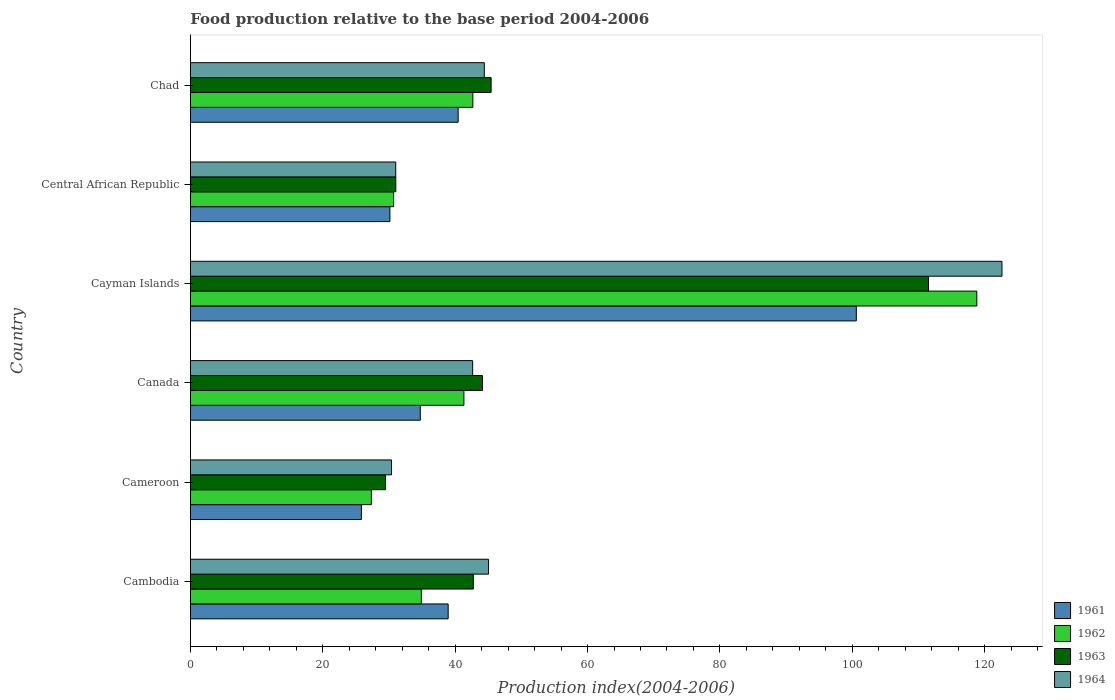How many different coloured bars are there?
Provide a succinct answer. 4. Are the number of bars on each tick of the Y-axis equal?
Offer a very short reply. Yes. How many bars are there on the 5th tick from the bottom?
Provide a short and direct response. 4. What is the label of the 6th group of bars from the top?
Your answer should be very brief. Cambodia. What is the food production index in 1964 in Central African Republic?
Provide a short and direct response. 31.03. Across all countries, what is the maximum food production index in 1964?
Give a very brief answer. 122.6. Across all countries, what is the minimum food production index in 1964?
Ensure brevity in your answer.  30.39. In which country was the food production index in 1964 maximum?
Make the answer very short. Cayman Islands. In which country was the food production index in 1962 minimum?
Your response must be concise. Cameroon. What is the total food production index in 1961 in the graph?
Ensure brevity in your answer.  270.74. What is the difference between the food production index in 1961 in Cayman Islands and that in Central African Republic?
Provide a short and direct response. 70.45. What is the difference between the food production index in 1964 in Cambodia and the food production index in 1962 in Canada?
Your answer should be very brief. 3.72. What is the average food production index in 1963 per country?
Your answer should be very brief. 50.73. What is the difference between the food production index in 1962 and food production index in 1963 in Chad?
Your response must be concise. -2.76. In how many countries, is the food production index in 1964 greater than 28 ?
Offer a terse response. 6. What is the ratio of the food production index in 1963 in Canada to that in Chad?
Provide a succinct answer. 0.97. What is the difference between the highest and the second highest food production index in 1964?
Ensure brevity in your answer.  77.55. What is the difference between the highest and the lowest food production index in 1962?
Make the answer very short. 91.45. In how many countries, is the food production index in 1963 greater than the average food production index in 1963 taken over all countries?
Make the answer very short. 1. What does the 1st bar from the bottom in Cameroon represents?
Make the answer very short. 1961. How many bars are there?
Offer a very short reply. 24. Are all the bars in the graph horizontal?
Offer a very short reply. Yes. What is the difference between two consecutive major ticks on the X-axis?
Offer a very short reply. 20. Are the values on the major ticks of X-axis written in scientific E-notation?
Give a very brief answer. No. Does the graph contain grids?
Provide a short and direct response. No. What is the title of the graph?
Give a very brief answer. Food production relative to the base period 2004-2006. What is the label or title of the X-axis?
Make the answer very short. Production index(2004-2006). What is the label or title of the Y-axis?
Provide a short and direct response. Country. What is the Production index(2004-2006) in 1961 in Cambodia?
Make the answer very short. 38.95. What is the Production index(2004-2006) of 1962 in Cambodia?
Keep it short and to the point. 34.9. What is the Production index(2004-2006) of 1963 in Cambodia?
Make the answer very short. 42.75. What is the Production index(2004-2006) in 1964 in Cambodia?
Offer a terse response. 45.05. What is the Production index(2004-2006) in 1961 in Cameroon?
Offer a very short reply. 25.84. What is the Production index(2004-2006) in 1962 in Cameroon?
Provide a short and direct response. 27.35. What is the Production index(2004-2006) of 1963 in Cameroon?
Your answer should be very brief. 29.49. What is the Production index(2004-2006) of 1964 in Cameroon?
Your answer should be compact. 30.39. What is the Production index(2004-2006) in 1961 in Canada?
Offer a very short reply. 34.74. What is the Production index(2004-2006) of 1962 in Canada?
Your answer should be very brief. 41.33. What is the Production index(2004-2006) in 1963 in Canada?
Ensure brevity in your answer.  44.13. What is the Production index(2004-2006) of 1964 in Canada?
Provide a short and direct response. 42.65. What is the Production index(2004-2006) in 1961 in Cayman Islands?
Your answer should be very brief. 100.6. What is the Production index(2004-2006) of 1962 in Cayman Islands?
Your answer should be compact. 118.8. What is the Production index(2004-2006) in 1963 in Cayman Islands?
Offer a terse response. 111.5. What is the Production index(2004-2006) in 1964 in Cayman Islands?
Offer a very short reply. 122.6. What is the Production index(2004-2006) in 1961 in Central African Republic?
Provide a succinct answer. 30.15. What is the Production index(2004-2006) in 1962 in Central African Republic?
Provide a succinct answer. 30.71. What is the Production index(2004-2006) of 1963 in Central African Republic?
Your answer should be compact. 31.04. What is the Production index(2004-2006) of 1964 in Central African Republic?
Give a very brief answer. 31.03. What is the Production index(2004-2006) in 1961 in Chad?
Your answer should be compact. 40.46. What is the Production index(2004-2006) in 1962 in Chad?
Give a very brief answer. 42.68. What is the Production index(2004-2006) in 1963 in Chad?
Offer a terse response. 45.44. What is the Production index(2004-2006) in 1964 in Chad?
Offer a terse response. 44.41. Across all countries, what is the maximum Production index(2004-2006) in 1961?
Keep it short and to the point. 100.6. Across all countries, what is the maximum Production index(2004-2006) in 1962?
Your answer should be compact. 118.8. Across all countries, what is the maximum Production index(2004-2006) in 1963?
Provide a succinct answer. 111.5. Across all countries, what is the maximum Production index(2004-2006) of 1964?
Offer a terse response. 122.6. Across all countries, what is the minimum Production index(2004-2006) of 1961?
Provide a succinct answer. 25.84. Across all countries, what is the minimum Production index(2004-2006) of 1962?
Your answer should be compact. 27.35. Across all countries, what is the minimum Production index(2004-2006) of 1963?
Offer a very short reply. 29.49. Across all countries, what is the minimum Production index(2004-2006) of 1964?
Your answer should be very brief. 30.39. What is the total Production index(2004-2006) of 1961 in the graph?
Make the answer very short. 270.74. What is the total Production index(2004-2006) in 1962 in the graph?
Ensure brevity in your answer.  295.77. What is the total Production index(2004-2006) of 1963 in the graph?
Provide a succinct answer. 304.35. What is the total Production index(2004-2006) of 1964 in the graph?
Offer a terse response. 316.13. What is the difference between the Production index(2004-2006) of 1961 in Cambodia and that in Cameroon?
Keep it short and to the point. 13.11. What is the difference between the Production index(2004-2006) in 1962 in Cambodia and that in Cameroon?
Your response must be concise. 7.55. What is the difference between the Production index(2004-2006) of 1963 in Cambodia and that in Cameroon?
Your answer should be compact. 13.26. What is the difference between the Production index(2004-2006) of 1964 in Cambodia and that in Cameroon?
Offer a very short reply. 14.66. What is the difference between the Production index(2004-2006) of 1961 in Cambodia and that in Canada?
Make the answer very short. 4.21. What is the difference between the Production index(2004-2006) of 1962 in Cambodia and that in Canada?
Make the answer very short. -6.43. What is the difference between the Production index(2004-2006) of 1963 in Cambodia and that in Canada?
Provide a succinct answer. -1.38. What is the difference between the Production index(2004-2006) in 1964 in Cambodia and that in Canada?
Make the answer very short. 2.4. What is the difference between the Production index(2004-2006) of 1961 in Cambodia and that in Cayman Islands?
Ensure brevity in your answer.  -61.65. What is the difference between the Production index(2004-2006) of 1962 in Cambodia and that in Cayman Islands?
Make the answer very short. -83.9. What is the difference between the Production index(2004-2006) of 1963 in Cambodia and that in Cayman Islands?
Offer a very short reply. -68.75. What is the difference between the Production index(2004-2006) in 1964 in Cambodia and that in Cayman Islands?
Your response must be concise. -77.55. What is the difference between the Production index(2004-2006) of 1962 in Cambodia and that in Central African Republic?
Your response must be concise. 4.19. What is the difference between the Production index(2004-2006) in 1963 in Cambodia and that in Central African Republic?
Give a very brief answer. 11.71. What is the difference between the Production index(2004-2006) in 1964 in Cambodia and that in Central African Republic?
Make the answer very short. 14.02. What is the difference between the Production index(2004-2006) in 1961 in Cambodia and that in Chad?
Your response must be concise. -1.51. What is the difference between the Production index(2004-2006) of 1962 in Cambodia and that in Chad?
Ensure brevity in your answer.  -7.78. What is the difference between the Production index(2004-2006) of 1963 in Cambodia and that in Chad?
Give a very brief answer. -2.69. What is the difference between the Production index(2004-2006) of 1964 in Cambodia and that in Chad?
Keep it short and to the point. 0.64. What is the difference between the Production index(2004-2006) in 1961 in Cameroon and that in Canada?
Your answer should be very brief. -8.9. What is the difference between the Production index(2004-2006) in 1962 in Cameroon and that in Canada?
Give a very brief answer. -13.98. What is the difference between the Production index(2004-2006) of 1963 in Cameroon and that in Canada?
Provide a succinct answer. -14.64. What is the difference between the Production index(2004-2006) in 1964 in Cameroon and that in Canada?
Provide a succinct answer. -12.26. What is the difference between the Production index(2004-2006) of 1961 in Cameroon and that in Cayman Islands?
Offer a very short reply. -74.76. What is the difference between the Production index(2004-2006) of 1962 in Cameroon and that in Cayman Islands?
Your response must be concise. -91.45. What is the difference between the Production index(2004-2006) of 1963 in Cameroon and that in Cayman Islands?
Your response must be concise. -82.01. What is the difference between the Production index(2004-2006) in 1964 in Cameroon and that in Cayman Islands?
Offer a terse response. -92.21. What is the difference between the Production index(2004-2006) in 1961 in Cameroon and that in Central African Republic?
Make the answer very short. -4.31. What is the difference between the Production index(2004-2006) in 1962 in Cameroon and that in Central African Republic?
Keep it short and to the point. -3.36. What is the difference between the Production index(2004-2006) of 1963 in Cameroon and that in Central African Republic?
Offer a very short reply. -1.55. What is the difference between the Production index(2004-2006) in 1964 in Cameroon and that in Central African Republic?
Provide a succinct answer. -0.64. What is the difference between the Production index(2004-2006) in 1961 in Cameroon and that in Chad?
Ensure brevity in your answer.  -14.62. What is the difference between the Production index(2004-2006) in 1962 in Cameroon and that in Chad?
Your response must be concise. -15.33. What is the difference between the Production index(2004-2006) in 1963 in Cameroon and that in Chad?
Provide a short and direct response. -15.95. What is the difference between the Production index(2004-2006) in 1964 in Cameroon and that in Chad?
Ensure brevity in your answer.  -14.02. What is the difference between the Production index(2004-2006) of 1961 in Canada and that in Cayman Islands?
Your answer should be very brief. -65.86. What is the difference between the Production index(2004-2006) in 1962 in Canada and that in Cayman Islands?
Ensure brevity in your answer.  -77.47. What is the difference between the Production index(2004-2006) in 1963 in Canada and that in Cayman Islands?
Your answer should be very brief. -67.37. What is the difference between the Production index(2004-2006) in 1964 in Canada and that in Cayman Islands?
Give a very brief answer. -79.95. What is the difference between the Production index(2004-2006) in 1961 in Canada and that in Central African Republic?
Ensure brevity in your answer.  4.59. What is the difference between the Production index(2004-2006) of 1962 in Canada and that in Central African Republic?
Keep it short and to the point. 10.62. What is the difference between the Production index(2004-2006) of 1963 in Canada and that in Central African Republic?
Your response must be concise. 13.09. What is the difference between the Production index(2004-2006) in 1964 in Canada and that in Central African Republic?
Offer a very short reply. 11.62. What is the difference between the Production index(2004-2006) in 1961 in Canada and that in Chad?
Ensure brevity in your answer.  -5.72. What is the difference between the Production index(2004-2006) in 1962 in Canada and that in Chad?
Provide a short and direct response. -1.35. What is the difference between the Production index(2004-2006) in 1963 in Canada and that in Chad?
Your answer should be very brief. -1.31. What is the difference between the Production index(2004-2006) of 1964 in Canada and that in Chad?
Keep it short and to the point. -1.76. What is the difference between the Production index(2004-2006) in 1961 in Cayman Islands and that in Central African Republic?
Your answer should be very brief. 70.45. What is the difference between the Production index(2004-2006) of 1962 in Cayman Islands and that in Central African Republic?
Your answer should be compact. 88.09. What is the difference between the Production index(2004-2006) of 1963 in Cayman Islands and that in Central African Republic?
Your response must be concise. 80.46. What is the difference between the Production index(2004-2006) of 1964 in Cayman Islands and that in Central African Republic?
Ensure brevity in your answer.  91.57. What is the difference between the Production index(2004-2006) of 1961 in Cayman Islands and that in Chad?
Make the answer very short. 60.14. What is the difference between the Production index(2004-2006) of 1962 in Cayman Islands and that in Chad?
Offer a terse response. 76.12. What is the difference between the Production index(2004-2006) in 1963 in Cayman Islands and that in Chad?
Provide a succinct answer. 66.06. What is the difference between the Production index(2004-2006) in 1964 in Cayman Islands and that in Chad?
Your answer should be very brief. 78.19. What is the difference between the Production index(2004-2006) in 1961 in Central African Republic and that in Chad?
Make the answer very short. -10.31. What is the difference between the Production index(2004-2006) of 1962 in Central African Republic and that in Chad?
Your response must be concise. -11.97. What is the difference between the Production index(2004-2006) of 1963 in Central African Republic and that in Chad?
Make the answer very short. -14.4. What is the difference between the Production index(2004-2006) in 1964 in Central African Republic and that in Chad?
Your response must be concise. -13.38. What is the difference between the Production index(2004-2006) in 1961 in Cambodia and the Production index(2004-2006) in 1963 in Cameroon?
Your answer should be very brief. 9.46. What is the difference between the Production index(2004-2006) in 1961 in Cambodia and the Production index(2004-2006) in 1964 in Cameroon?
Make the answer very short. 8.56. What is the difference between the Production index(2004-2006) of 1962 in Cambodia and the Production index(2004-2006) of 1963 in Cameroon?
Make the answer very short. 5.41. What is the difference between the Production index(2004-2006) in 1962 in Cambodia and the Production index(2004-2006) in 1964 in Cameroon?
Offer a terse response. 4.51. What is the difference between the Production index(2004-2006) of 1963 in Cambodia and the Production index(2004-2006) of 1964 in Cameroon?
Provide a short and direct response. 12.36. What is the difference between the Production index(2004-2006) in 1961 in Cambodia and the Production index(2004-2006) in 1962 in Canada?
Give a very brief answer. -2.38. What is the difference between the Production index(2004-2006) of 1961 in Cambodia and the Production index(2004-2006) of 1963 in Canada?
Ensure brevity in your answer.  -5.18. What is the difference between the Production index(2004-2006) of 1961 in Cambodia and the Production index(2004-2006) of 1964 in Canada?
Make the answer very short. -3.7. What is the difference between the Production index(2004-2006) in 1962 in Cambodia and the Production index(2004-2006) in 1963 in Canada?
Provide a short and direct response. -9.23. What is the difference between the Production index(2004-2006) of 1962 in Cambodia and the Production index(2004-2006) of 1964 in Canada?
Give a very brief answer. -7.75. What is the difference between the Production index(2004-2006) in 1963 in Cambodia and the Production index(2004-2006) in 1964 in Canada?
Offer a terse response. 0.1. What is the difference between the Production index(2004-2006) in 1961 in Cambodia and the Production index(2004-2006) in 1962 in Cayman Islands?
Make the answer very short. -79.85. What is the difference between the Production index(2004-2006) of 1961 in Cambodia and the Production index(2004-2006) of 1963 in Cayman Islands?
Provide a short and direct response. -72.55. What is the difference between the Production index(2004-2006) in 1961 in Cambodia and the Production index(2004-2006) in 1964 in Cayman Islands?
Your answer should be very brief. -83.65. What is the difference between the Production index(2004-2006) in 1962 in Cambodia and the Production index(2004-2006) in 1963 in Cayman Islands?
Your answer should be compact. -76.6. What is the difference between the Production index(2004-2006) of 1962 in Cambodia and the Production index(2004-2006) of 1964 in Cayman Islands?
Offer a terse response. -87.7. What is the difference between the Production index(2004-2006) of 1963 in Cambodia and the Production index(2004-2006) of 1964 in Cayman Islands?
Offer a very short reply. -79.85. What is the difference between the Production index(2004-2006) in 1961 in Cambodia and the Production index(2004-2006) in 1962 in Central African Republic?
Offer a terse response. 8.24. What is the difference between the Production index(2004-2006) in 1961 in Cambodia and the Production index(2004-2006) in 1963 in Central African Republic?
Provide a short and direct response. 7.91. What is the difference between the Production index(2004-2006) of 1961 in Cambodia and the Production index(2004-2006) of 1964 in Central African Republic?
Ensure brevity in your answer.  7.92. What is the difference between the Production index(2004-2006) in 1962 in Cambodia and the Production index(2004-2006) in 1963 in Central African Republic?
Offer a very short reply. 3.86. What is the difference between the Production index(2004-2006) of 1962 in Cambodia and the Production index(2004-2006) of 1964 in Central African Republic?
Make the answer very short. 3.87. What is the difference between the Production index(2004-2006) of 1963 in Cambodia and the Production index(2004-2006) of 1964 in Central African Republic?
Your response must be concise. 11.72. What is the difference between the Production index(2004-2006) in 1961 in Cambodia and the Production index(2004-2006) in 1962 in Chad?
Provide a succinct answer. -3.73. What is the difference between the Production index(2004-2006) of 1961 in Cambodia and the Production index(2004-2006) of 1963 in Chad?
Ensure brevity in your answer.  -6.49. What is the difference between the Production index(2004-2006) in 1961 in Cambodia and the Production index(2004-2006) in 1964 in Chad?
Your answer should be compact. -5.46. What is the difference between the Production index(2004-2006) in 1962 in Cambodia and the Production index(2004-2006) in 1963 in Chad?
Offer a very short reply. -10.54. What is the difference between the Production index(2004-2006) in 1962 in Cambodia and the Production index(2004-2006) in 1964 in Chad?
Your response must be concise. -9.51. What is the difference between the Production index(2004-2006) in 1963 in Cambodia and the Production index(2004-2006) in 1964 in Chad?
Offer a very short reply. -1.66. What is the difference between the Production index(2004-2006) in 1961 in Cameroon and the Production index(2004-2006) in 1962 in Canada?
Offer a terse response. -15.49. What is the difference between the Production index(2004-2006) of 1961 in Cameroon and the Production index(2004-2006) of 1963 in Canada?
Keep it short and to the point. -18.29. What is the difference between the Production index(2004-2006) in 1961 in Cameroon and the Production index(2004-2006) in 1964 in Canada?
Ensure brevity in your answer.  -16.81. What is the difference between the Production index(2004-2006) in 1962 in Cameroon and the Production index(2004-2006) in 1963 in Canada?
Offer a terse response. -16.78. What is the difference between the Production index(2004-2006) of 1962 in Cameroon and the Production index(2004-2006) of 1964 in Canada?
Your response must be concise. -15.3. What is the difference between the Production index(2004-2006) of 1963 in Cameroon and the Production index(2004-2006) of 1964 in Canada?
Your answer should be compact. -13.16. What is the difference between the Production index(2004-2006) of 1961 in Cameroon and the Production index(2004-2006) of 1962 in Cayman Islands?
Give a very brief answer. -92.96. What is the difference between the Production index(2004-2006) of 1961 in Cameroon and the Production index(2004-2006) of 1963 in Cayman Islands?
Offer a terse response. -85.66. What is the difference between the Production index(2004-2006) in 1961 in Cameroon and the Production index(2004-2006) in 1964 in Cayman Islands?
Your response must be concise. -96.76. What is the difference between the Production index(2004-2006) in 1962 in Cameroon and the Production index(2004-2006) in 1963 in Cayman Islands?
Ensure brevity in your answer.  -84.15. What is the difference between the Production index(2004-2006) in 1962 in Cameroon and the Production index(2004-2006) in 1964 in Cayman Islands?
Your response must be concise. -95.25. What is the difference between the Production index(2004-2006) of 1963 in Cameroon and the Production index(2004-2006) of 1964 in Cayman Islands?
Your answer should be very brief. -93.11. What is the difference between the Production index(2004-2006) of 1961 in Cameroon and the Production index(2004-2006) of 1962 in Central African Republic?
Ensure brevity in your answer.  -4.87. What is the difference between the Production index(2004-2006) in 1961 in Cameroon and the Production index(2004-2006) in 1964 in Central African Republic?
Your response must be concise. -5.19. What is the difference between the Production index(2004-2006) of 1962 in Cameroon and the Production index(2004-2006) of 1963 in Central African Republic?
Keep it short and to the point. -3.69. What is the difference between the Production index(2004-2006) of 1962 in Cameroon and the Production index(2004-2006) of 1964 in Central African Republic?
Your answer should be compact. -3.68. What is the difference between the Production index(2004-2006) of 1963 in Cameroon and the Production index(2004-2006) of 1964 in Central African Republic?
Keep it short and to the point. -1.54. What is the difference between the Production index(2004-2006) in 1961 in Cameroon and the Production index(2004-2006) in 1962 in Chad?
Provide a succinct answer. -16.84. What is the difference between the Production index(2004-2006) of 1961 in Cameroon and the Production index(2004-2006) of 1963 in Chad?
Offer a terse response. -19.6. What is the difference between the Production index(2004-2006) of 1961 in Cameroon and the Production index(2004-2006) of 1964 in Chad?
Your answer should be very brief. -18.57. What is the difference between the Production index(2004-2006) in 1962 in Cameroon and the Production index(2004-2006) in 1963 in Chad?
Your response must be concise. -18.09. What is the difference between the Production index(2004-2006) in 1962 in Cameroon and the Production index(2004-2006) in 1964 in Chad?
Provide a succinct answer. -17.06. What is the difference between the Production index(2004-2006) of 1963 in Cameroon and the Production index(2004-2006) of 1964 in Chad?
Offer a terse response. -14.92. What is the difference between the Production index(2004-2006) in 1961 in Canada and the Production index(2004-2006) in 1962 in Cayman Islands?
Provide a succinct answer. -84.06. What is the difference between the Production index(2004-2006) of 1961 in Canada and the Production index(2004-2006) of 1963 in Cayman Islands?
Give a very brief answer. -76.76. What is the difference between the Production index(2004-2006) of 1961 in Canada and the Production index(2004-2006) of 1964 in Cayman Islands?
Provide a succinct answer. -87.86. What is the difference between the Production index(2004-2006) in 1962 in Canada and the Production index(2004-2006) in 1963 in Cayman Islands?
Your answer should be very brief. -70.17. What is the difference between the Production index(2004-2006) of 1962 in Canada and the Production index(2004-2006) of 1964 in Cayman Islands?
Your answer should be compact. -81.27. What is the difference between the Production index(2004-2006) of 1963 in Canada and the Production index(2004-2006) of 1964 in Cayman Islands?
Make the answer very short. -78.47. What is the difference between the Production index(2004-2006) in 1961 in Canada and the Production index(2004-2006) in 1962 in Central African Republic?
Your answer should be compact. 4.03. What is the difference between the Production index(2004-2006) of 1961 in Canada and the Production index(2004-2006) of 1964 in Central African Republic?
Your response must be concise. 3.71. What is the difference between the Production index(2004-2006) of 1962 in Canada and the Production index(2004-2006) of 1963 in Central African Republic?
Provide a succinct answer. 10.29. What is the difference between the Production index(2004-2006) in 1962 in Canada and the Production index(2004-2006) in 1964 in Central African Republic?
Your answer should be very brief. 10.3. What is the difference between the Production index(2004-2006) in 1963 in Canada and the Production index(2004-2006) in 1964 in Central African Republic?
Give a very brief answer. 13.1. What is the difference between the Production index(2004-2006) of 1961 in Canada and the Production index(2004-2006) of 1962 in Chad?
Give a very brief answer. -7.94. What is the difference between the Production index(2004-2006) in 1961 in Canada and the Production index(2004-2006) in 1963 in Chad?
Provide a succinct answer. -10.7. What is the difference between the Production index(2004-2006) of 1961 in Canada and the Production index(2004-2006) of 1964 in Chad?
Ensure brevity in your answer.  -9.67. What is the difference between the Production index(2004-2006) of 1962 in Canada and the Production index(2004-2006) of 1963 in Chad?
Your answer should be compact. -4.11. What is the difference between the Production index(2004-2006) in 1962 in Canada and the Production index(2004-2006) in 1964 in Chad?
Your response must be concise. -3.08. What is the difference between the Production index(2004-2006) of 1963 in Canada and the Production index(2004-2006) of 1964 in Chad?
Your answer should be compact. -0.28. What is the difference between the Production index(2004-2006) of 1961 in Cayman Islands and the Production index(2004-2006) of 1962 in Central African Republic?
Your response must be concise. 69.89. What is the difference between the Production index(2004-2006) of 1961 in Cayman Islands and the Production index(2004-2006) of 1963 in Central African Republic?
Offer a terse response. 69.56. What is the difference between the Production index(2004-2006) of 1961 in Cayman Islands and the Production index(2004-2006) of 1964 in Central African Republic?
Provide a short and direct response. 69.57. What is the difference between the Production index(2004-2006) in 1962 in Cayman Islands and the Production index(2004-2006) in 1963 in Central African Republic?
Your answer should be compact. 87.76. What is the difference between the Production index(2004-2006) of 1962 in Cayman Islands and the Production index(2004-2006) of 1964 in Central African Republic?
Make the answer very short. 87.77. What is the difference between the Production index(2004-2006) of 1963 in Cayman Islands and the Production index(2004-2006) of 1964 in Central African Republic?
Your response must be concise. 80.47. What is the difference between the Production index(2004-2006) in 1961 in Cayman Islands and the Production index(2004-2006) in 1962 in Chad?
Your response must be concise. 57.92. What is the difference between the Production index(2004-2006) in 1961 in Cayman Islands and the Production index(2004-2006) in 1963 in Chad?
Make the answer very short. 55.16. What is the difference between the Production index(2004-2006) in 1961 in Cayman Islands and the Production index(2004-2006) in 1964 in Chad?
Make the answer very short. 56.19. What is the difference between the Production index(2004-2006) in 1962 in Cayman Islands and the Production index(2004-2006) in 1963 in Chad?
Offer a very short reply. 73.36. What is the difference between the Production index(2004-2006) of 1962 in Cayman Islands and the Production index(2004-2006) of 1964 in Chad?
Provide a short and direct response. 74.39. What is the difference between the Production index(2004-2006) of 1963 in Cayman Islands and the Production index(2004-2006) of 1964 in Chad?
Your answer should be compact. 67.09. What is the difference between the Production index(2004-2006) of 1961 in Central African Republic and the Production index(2004-2006) of 1962 in Chad?
Offer a very short reply. -12.53. What is the difference between the Production index(2004-2006) in 1961 in Central African Republic and the Production index(2004-2006) in 1963 in Chad?
Provide a succinct answer. -15.29. What is the difference between the Production index(2004-2006) in 1961 in Central African Republic and the Production index(2004-2006) in 1964 in Chad?
Your response must be concise. -14.26. What is the difference between the Production index(2004-2006) in 1962 in Central African Republic and the Production index(2004-2006) in 1963 in Chad?
Ensure brevity in your answer.  -14.73. What is the difference between the Production index(2004-2006) of 1962 in Central African Republic and the Production index(2004-2006) of 1964 in Chad?
Offer a very short reply. -13.7. What is the difference between the Production index(2004-2006) in 1963 in Central African Republic and the Production index(2004-2006) in 1964 in Chad?
Your answer should be very brief. -13.37. What is the average Production index(2004-2006) of 1961 per country?
Offer a very short reply. 45.12. What is the average Production index(2004-2006) of 1962 per country?
Your response must be concise. 49.3. What is the average Production index(2004-2006) in 1963 per country?
Your answer should be very brief. 50.73. What is the average Production index(2004-2006) of 1964 per country?
Give a very brief answer. 52.69. What is the difference between the Production index(2004-2006) of 1961 and Production index(2004-2006) of 1962 in Cambodia?
Ensure brevity in your answer.  4.05. What is the difference between the Production index(2004-2006) in 1962 and Production index(2004-2006) in 1963 in Cambodia?
Give a very brief answer. -7.85. What is the difference between the Production index(2004-2006) in 1962 and Production index(2004-2006) in 1964 in Cambodia?
Offer a terse response. -10.15. What is the difference between the Production index(2004-2006) of 1963 and Production index(2004-2006) of 1964 in Cambodia?
Your answer should be very brief. -2.3. What is the difference between the Production index(2004-2006) of 1961 and Production index(2004-2006) of 1962 in Cameroon?
Give a very brief answer. -1.51. What is the difference between the Production index(2004-2006) of 1961 and Production index(2004-2006) of 1963 in Cameroon?
Offer a terse response. -3.65. What is the difference between the Production index(2004-2006) in 1961 and Production index(2004-2006) in 1964 in Cameroon?
Keep it short and to the point. -4.55. What is the difference between the Production index(2004-2006) of 1962 and Production index(2004-2006) of 1963 in Cameroon?
Your answer should be compact. -2.14. What is the difference between the Production index(2004-2006) of 1962 and Production index(2004-2006) of 1964 in Cameroon?
Make the answer very short. -3.04. What is the difference between the Production index(2004-2006) of 1961 and Production index(2004-2006) of 1962 in Canada?
Offer a terse response. -6.59. What is the difference between the Production index(2004-2006) in 1961 and Production index(2004-2006) in 1963 in Canada?
Make the answer very short. -9.39. What is the difference between the Production index(2004-2006) of 1961 and Production index(2004-2006) of 1964 in Canada?
Ensure brevity in your answer.  -7.91. What is the difference between the Production index(2004-2006) of 1962 and Production index(2004-2006) of 1963 in Canada?
Offer a very short reply. -2.8. What is the difference between the Production index(2004-2006) of 1962 and Production index(2004-2006) of 1964 in Canada?
Your answer should be very brief. -1.32. What is the difference between the Production index(2004-2006) in 1963 and Production index(2004-2006) in 1964 in Canada?
Give a very brief answer. 1.48. What is the difference between the Production index(2004-2006) in 1961 and Production index(2004-2006) in 1962 in Cayman Islands?
Offer a very short reply. -18.2. What is the difference between the Production index(2004-2006) of 1961 and Production index(2004-2006) of 1963 in Cayman Islands?
Offer a terse response. -10.9. What is the difference between the Production index(2004-2006) of 1962 and Production index(2004-2006) of 1964 in Cayman Islands?
Provide a short and direct response. -3.8. What is the difference between the Production index(2004-2006) in 1961 and Production index(2004-2006) in 1962 in Central African Republic?
Your answer should be compact. -0.56. What is the difference between the Production index(2004-2006) of 1961 and Production index(2004-2006) of 1963 in Central African Republic?
Offer a terse response. -0.89. What is the difference between the Production index(2004-2006) in 1961 and Production index(2004-2006) in 1964 in Central African Republic?
Your answer should be very brief. -0.88. What is the difference between the Production index(2004-2006) in 1962 and Production index(2004-2006) in 1963 in Central African Republic?
Your answer should be compact. -0.33. What is the difference between the Production index(2004-2006) of 1962 and Production index(2004-2006) of 1964 in Central African Republic?
Offer a very short reply. -0.32. What is the difference between the Production index(2004-2006) of 1961 and Production index(2004-2006) of 1962 in Chad?
Keep it short and to the point. -2.22. What is the difference between the Production index(2004-2006) of 1961 and Production index(2004-2006) of 1963 in Chad?
Your response must be concise. -4.98. What is the difference between the Production index(2004-2006) in 1961 and Production index(2004-2006) in 1964 in Chad?
Provide a succinct answer. -3.95. What is the difference between the Production index(2004-2006) in 1962 and Production index(2004-2006) in 1963 in Chad?
Your answer should be compact. -2.76. What is the difference between the Production index(2004-2006) of 1962 and Production index(2004-2006) of 1964 in Chad?
Offer a terse response. -1.73. What is the ratio of the Production index(2004-2006) of 1961 in Cambodia to that in Cameroon?
Provide a succinct answer. 1.51. What is the ratio of the Production index(2004-2006) in 1962 in Cambodia to that in Cameroon?
Ensure brevity in your answer.  1.28. What is the ratio of the Production index(2004-2006) of 1963 in Cambodia to that in Cameroon?
Provide a short and direct response. 1.45. What is the ratio of the Production index(2004-2006) in 1964 in Cambodia to that in Cameroon?
Offer a terse response. 1.48. What is the ratio of the Production index(2004-2006) in 1961 in Cambodia to that in Canada?
Your answer should be compact. 1.12. What is the ratio of the Production index(2004-2006) in 1962 in Cambodia to that in Canada?
Give a very brief answer. 0.84. What is the ratio of the Production index(2004-2006) of 1963 in Cambodia to that in Canada?
Keep it short and to the point. 0.97. What is the ratio of the Production index(2004-2006) in 1964 in Cambodia to that in Canada?
Offer a very short reply. 1.06. What is the ratio of the Production index(2004-2006) of 1961 in Cambodia to that in Cayman Islands?
Give a very brief answer. 0.39. What is the ratio of the Production index(2004-2006) in 1962 in Cambodia to that in Cayman Islands?
Make the answer very short. 0.29. What is the ratio of the Production index(2004-2006) in 1963 in Cambodia to that in Cayman Islands?
Your answer should be compact. 0.38. What is the ratio of the Production index(2004-2006) in 1964 in Cambodia to that in Cayman Islands?
Your answer should be compact. 0.37. What is the ratio of the Production index(2004-2006) in 1961 in Cambodia to that in Central African Republic?
Keep it short and to the point. 1.29. What is the ratio of the Production index(2004-2006) in 1962 in Cambodia to that in Central African Republic?
Give a very brief answer. 1.14. What is the ratio of the Production index(2004-2006) of 1963 in Cambodia to that in Central African Republic?
Keep it short and to the point. 1.38. What is the ratio of the Production index(2004-2006) of 1964 in Cambodia to that in Central African Republic?
Make the answer very short. 1.45. What is the ratio of the Production index(2004-2006) of 1961 in Cambodia to that in Chad?
Your answer should be compact. 0.96. What is the ratio of the Production index(2004-2006) of 1962 in Cambodia to that in Chad?
Offer a very short reply. 0.82. What is the ratio of the Production index(2004-2006) of 1963 in Cambodia to that in Chad?
Give a very brief answer. 0.94. What is the ratio of the Production index(2004-2006) of 1964 in Cambodia to that in Chad?
Ensure brevity in your answer.  1.01. What is the ratio of the Production index(2004-2006) of 1961 in Cameroon to that in Canada?
Keep it short and to the point. 0.74. What is the ratio of the Production index(2004-2006) of 1962 in Cameroon to that in Canada?
Provide a succinct answer. 0.66. What is the ratio of the Production index(2004-2006) in 1963 in Cameroon to that in Canada?
Your answer should be very brief. 0.67. What is the ratio of the Production index(2004-2006) of 1964 in Cameroon to that in Canada?
Ensure brevity in your answer.  0.71. What is the ratio of the Production index(2004-2006) of 1961 in Cameroon to that in Cayman Islands?
Keep it short and to the point. 0.26. What is the ratio of the Production index(2004-2006) in 1962 in Cameroon to that in Cayman Islands?
Your response must be concise. 0.23. What is the ratio of the Production index(2004-2006) in 1963 in Cameroon to that in Cayman Islands?
Offer a very short reply. 0.26. What is the ratio of the Production index(2004-2006) of 1964 in Cameroon to that in Cayman Islands?
Your answer should be very brief. 0.25. What is the ratio of the Production index(2004-2006) of 1961 in Cameroon to that in Central African Republic?
Your answer should be compact. 0.86. What is the ratio of the Production index(2004-2006) of 1962 in Cameroon to that in Central African Republic?
Provide a short and direct response. 0.89. What is the ratio of the Production index(2004-2006) of 1963 in Cameroon to that in Central African Republic?
Ensure brevity in your answer.  0.95. What is the ratio of the Production index(2004-2006) in 1964 in Cameroon to that in Central African Republic?
Your response must be concise. 0.98. What is the ratio of the Production index(2004-2006) in 1961 in Cameroon to that in Chad?
Your response must be concise. 0.64. What is the ratio of the Production index(2004-2006) of 1962 in Cameroon to that in Chad?
Your answer should be compact. 0.64. What is the ratio of the Production index(2004-2006) of 1963 in Cameroon to that in Chad?
Make the answer very short. 0.65. What is the ratio of the Production index(2004-2006) in 1964 in Cameroon to that in Chad?
Give a very brief answer. 0.68. What is the ratio of the Production index(2004-2006) in 1961 in Canada to that in Cayman Islands?
Offer a very short reply. 0.35. What is the ratio of the Production index(2004-2006) in 1962 in Canada to that in Cayman Islands?
Offer a very short reply. 0.35. What is the ratio of the Production index(2004-2006) of 1963 in Canada to that in Cayman Islands?
Ensure brevity in your answer.  0.4. What is the ratio of the Production index(2004-2006) in 1964 in Canada to that in Cayman Islands?
Provide a short and direct response. 0.35. What is the ratio of the Production index(2004-2006) in 1961 in Canada to that in Central African Republic?
Ensure brevity in your answer.  1.15. What is the ratio of the Production index(2004-2006) in 1962 in Canada to that in Central African Republic?
Make the answer very short. 1.35. What is the ratio of the Production index(2004-2006) in 1963 in Canada to that in Central African Republic?
Offer a terse response. 1.42. What is the ratio of the Production index(2004-2006) of 1964 in Canada to that in Central African Republic?
Keep it short and to the point. 1.37. What is the ratio of the Production index(2004-2006) of 1961 in Canada to that in Chad?
Your answer should be very brief. 0.86. What is the ratio of the Production index(2004-2006) of 1962 in Canada to that in Chad?
Make the answer very short. 0.97. What is the ratio of the Production index(2004-2006) in 1963 in Canada to that in Chad?
Keep it short and to the point. 0.97. What is the ratio of the Production index(2004-2006) in 1964 in Canada to that in Chad?
Provide a short and direct response. 0.96. What is the ratio of the Production index(2004-2006) in 1961 in Cayman Islands to that in Central African Republic?
Keep it short and to the point. 3.34. What is the ratio of the Production index(2004-2006) in 1962 in Cayman Islands to that in Central African Republic?
Keep it short and to the point. 3.87. What is the ratio of the Production index(2004-2006) of 1963 in Cayman Islands to that in Central African Republic?
Make the answer very short. 3.59. What is the ratio of the Production index(2004-2006) in 1964 in Cayman Islands to that in Central African Republic?
Provide a succinct answer. 3.95. What is the ratio of the Production index(2004-2006) in 1961 in Cayman Islands to that in Chad?
Offer a very short reply. 2.49. What is the ratio of the Production index(2004-2006) in 1962 in Cayman Islands to that in Chad?
Ensure brevity in your answer.  2.78. What is the ratio of the Production index(2004-2006) of 1963 in Cayman Islands to that in Chad?
Make the answer very short. 2.45. What is the ratio of the Production index(2004-2006) in 1964 in Cayman Islands to that in Chad?
Your response must be concise. 2.76. What is the ratio of the Production index(2004-2006) in 1961 in Central African Republic to that in Chad?
Offer a very short reply. 0.75. What is the ratio of the Production index(2004-2006) of 1962 in Central African Republic to that in Chad?
Offer a very short reply. 0.72. What is the ratio of the Production index(2004-2006) of 1963 in Central African Republic to that in Chad?
Your answer should be compact. 0.68. What is the ratio of the Production index(2004-2006) of 1964 in Central African Republic to that in Chad?
Offer a terse response. 0.7. What is the difference between the highest and the second highest Production index(2004-2006) in 1961?
Provide a succinct answer. 60.14. What is the difference between the highest and the second highest Production index(2004-2006) of 1962?
Make the answer very short. 76.12. What is the difference between the highest and the second highest Production index(2004-2006) of 1963?
Your response must be concise. 66.06. What is the difference between the highest and the second highest Production index(2004-2006) of 1964?
Give a very brief answer. 77.55. What is the difference between the highest and the lowest Production index(2004-2006) in 1961?
Keep it short and to the point. 74.76. What is the difference between the highest and the lowest Production index(2004-2006) of 1962?
Give a very brief answer. 91.45. What is the difference between the highest and the lowest Production index(2004-2006) of 1963?
Provide a succinct answer. 82.01. What is the difference between the highest and the lowest Production index(2004-2006) of 1964?
Your response must be concise. 92.21. 